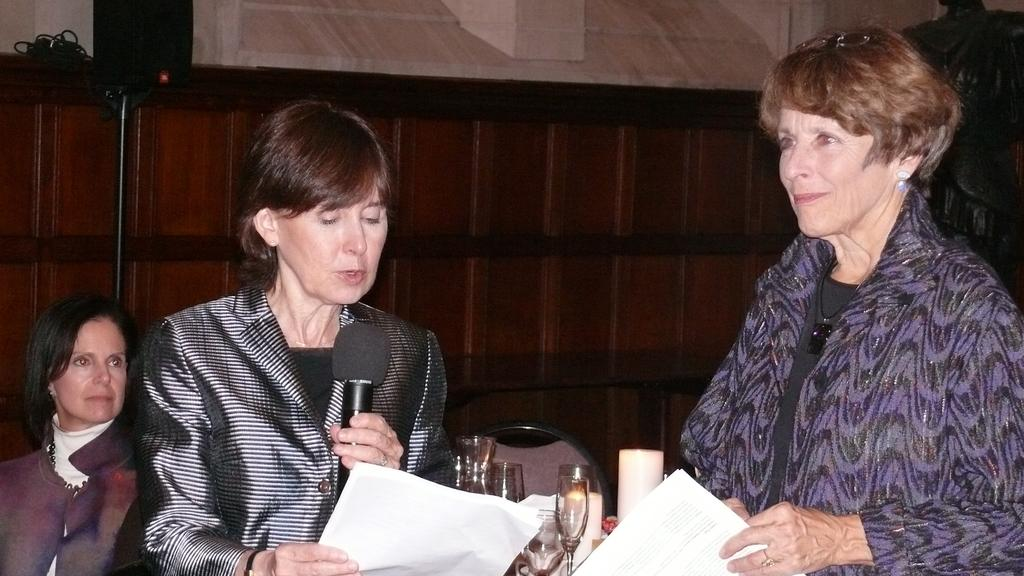How many women are in the image? There are two women in the image. What are the women doing in the image? The women are standing and holding microphones and paper. What else can be seen in the image? There is a glass and a chair in the image. Are there any boats visible in the image? No, there are no boats present in the image. What type of coal is being used by the women in the image? There is no coal present in the image; the women are holding microphones and paper. 